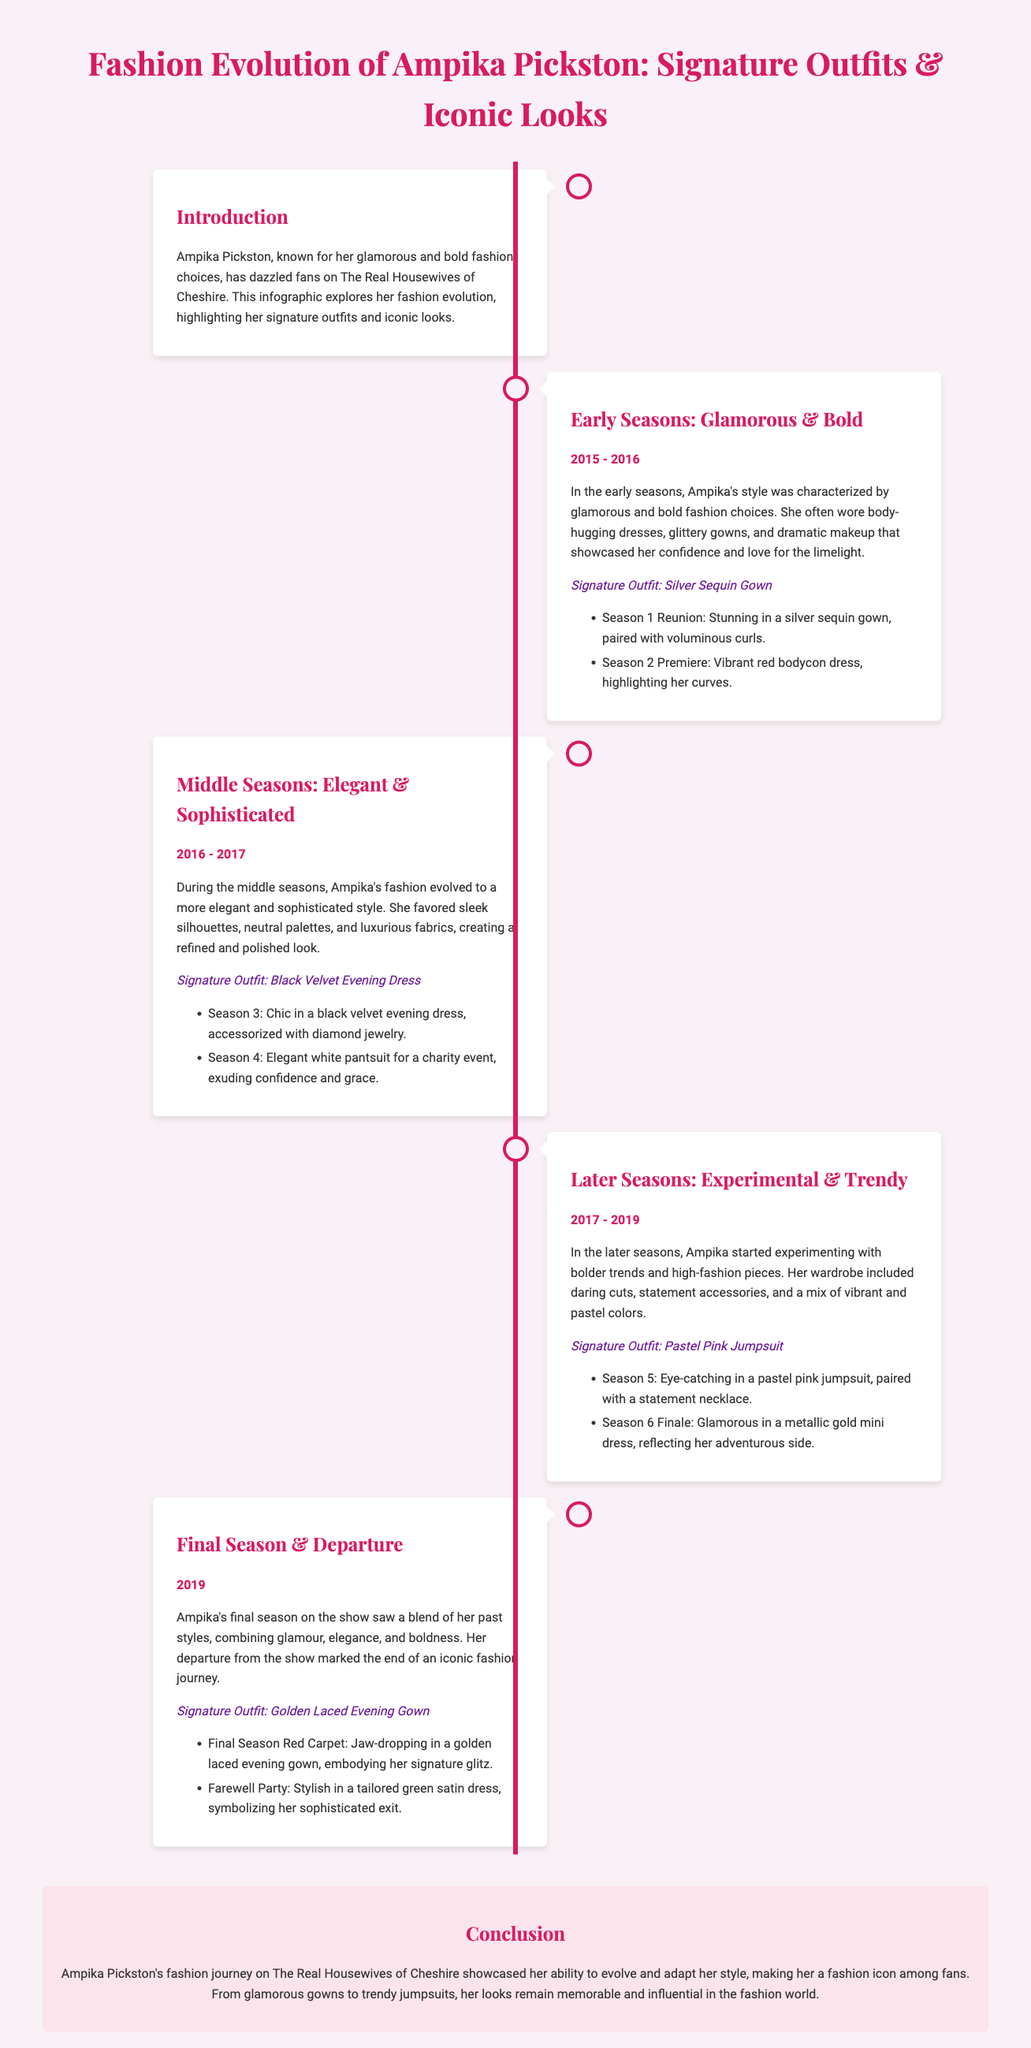What is the title of the infographic? The title of the infographic is stated at the top, reflecting the content.
Answer: Fashion Evolution of Ampika Pickston: Signature Outfits & Iconic Looks What is Ampika's signature outfit in the early seasons? The signature outfit during the early seasons is highlighted in the document.
Answer: Silver Sequin Gown Which years are covered in the middle seasons? The years during the middle seasons are explicitly listed in the timeline.
Answer: 2016 - 2017 What type of fashion does Ampika represent in the later seasons? The description of her style during the later seasons indicates how her fashion has changed.
Answer: Experimental & Trendy In what year did Ampika leave the show? The document specifies the year related to her departure.
Answer: 2019 What was her signature outfit in the final season? The signature outfit for her final season is noted in the section describing it.
Answer: Golden Laced Evening Gown Which outfit did Ampika wear at the Season 1 Reunion? The notable moment related to Season 1 Reunion gives insight into her fashion choices.
Answer: Silver sequin gown What characterized Ampika's style during the middle seasons? The characteristic of her style during the middle seasons is detailed in the section.
Answer: Elegant & Sophisticated How many notable moments are listed for the later seasons? The document includes a specific number of moments showcased for the later seasons.
Answer: 2 